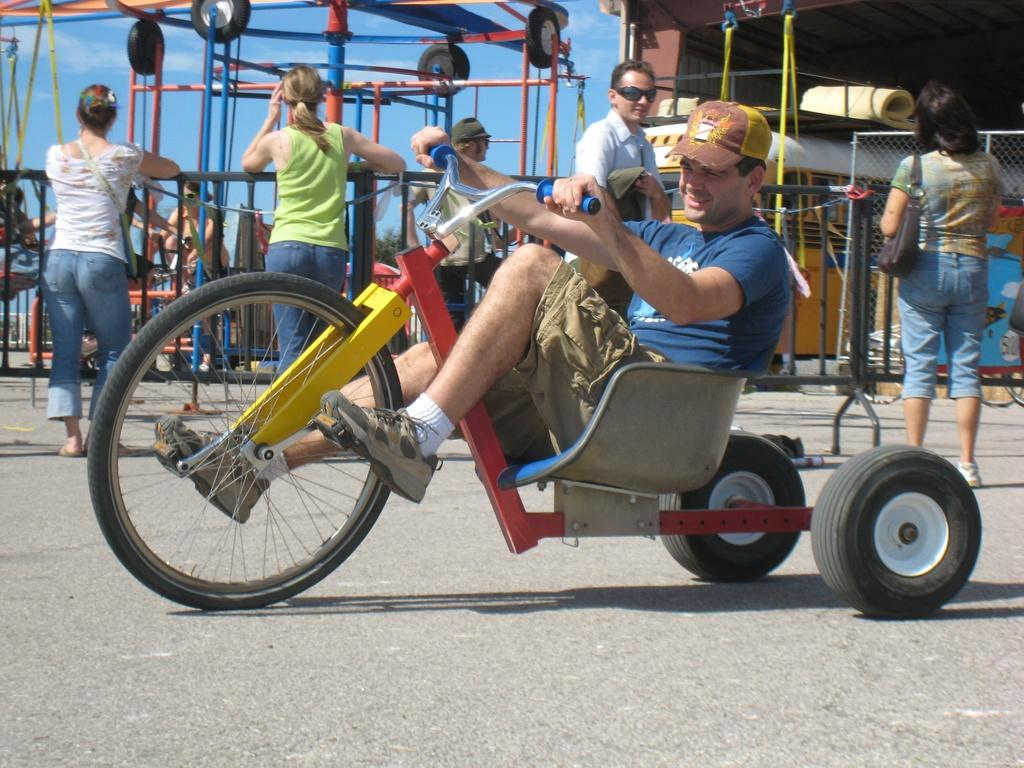What are the people in the image doing? There are persons standing in the image, and one person is sitting and riding a vehicle. Can you describe the person riding the vehicle? The person riding the vehicle is wearing a bag. What can be seen in the background of the image? There is sky, vehicles on the road, and a fence visible in the background of the image. What type of anger is the person riding the vehicle experiencing in the image? There is no indication of anger in the image; the person riding the vehicle is simply wearing a bag and riding a vehicle. What is being prepared for dinner in the image? There is no reference to dinner or any food preparation in the image. 